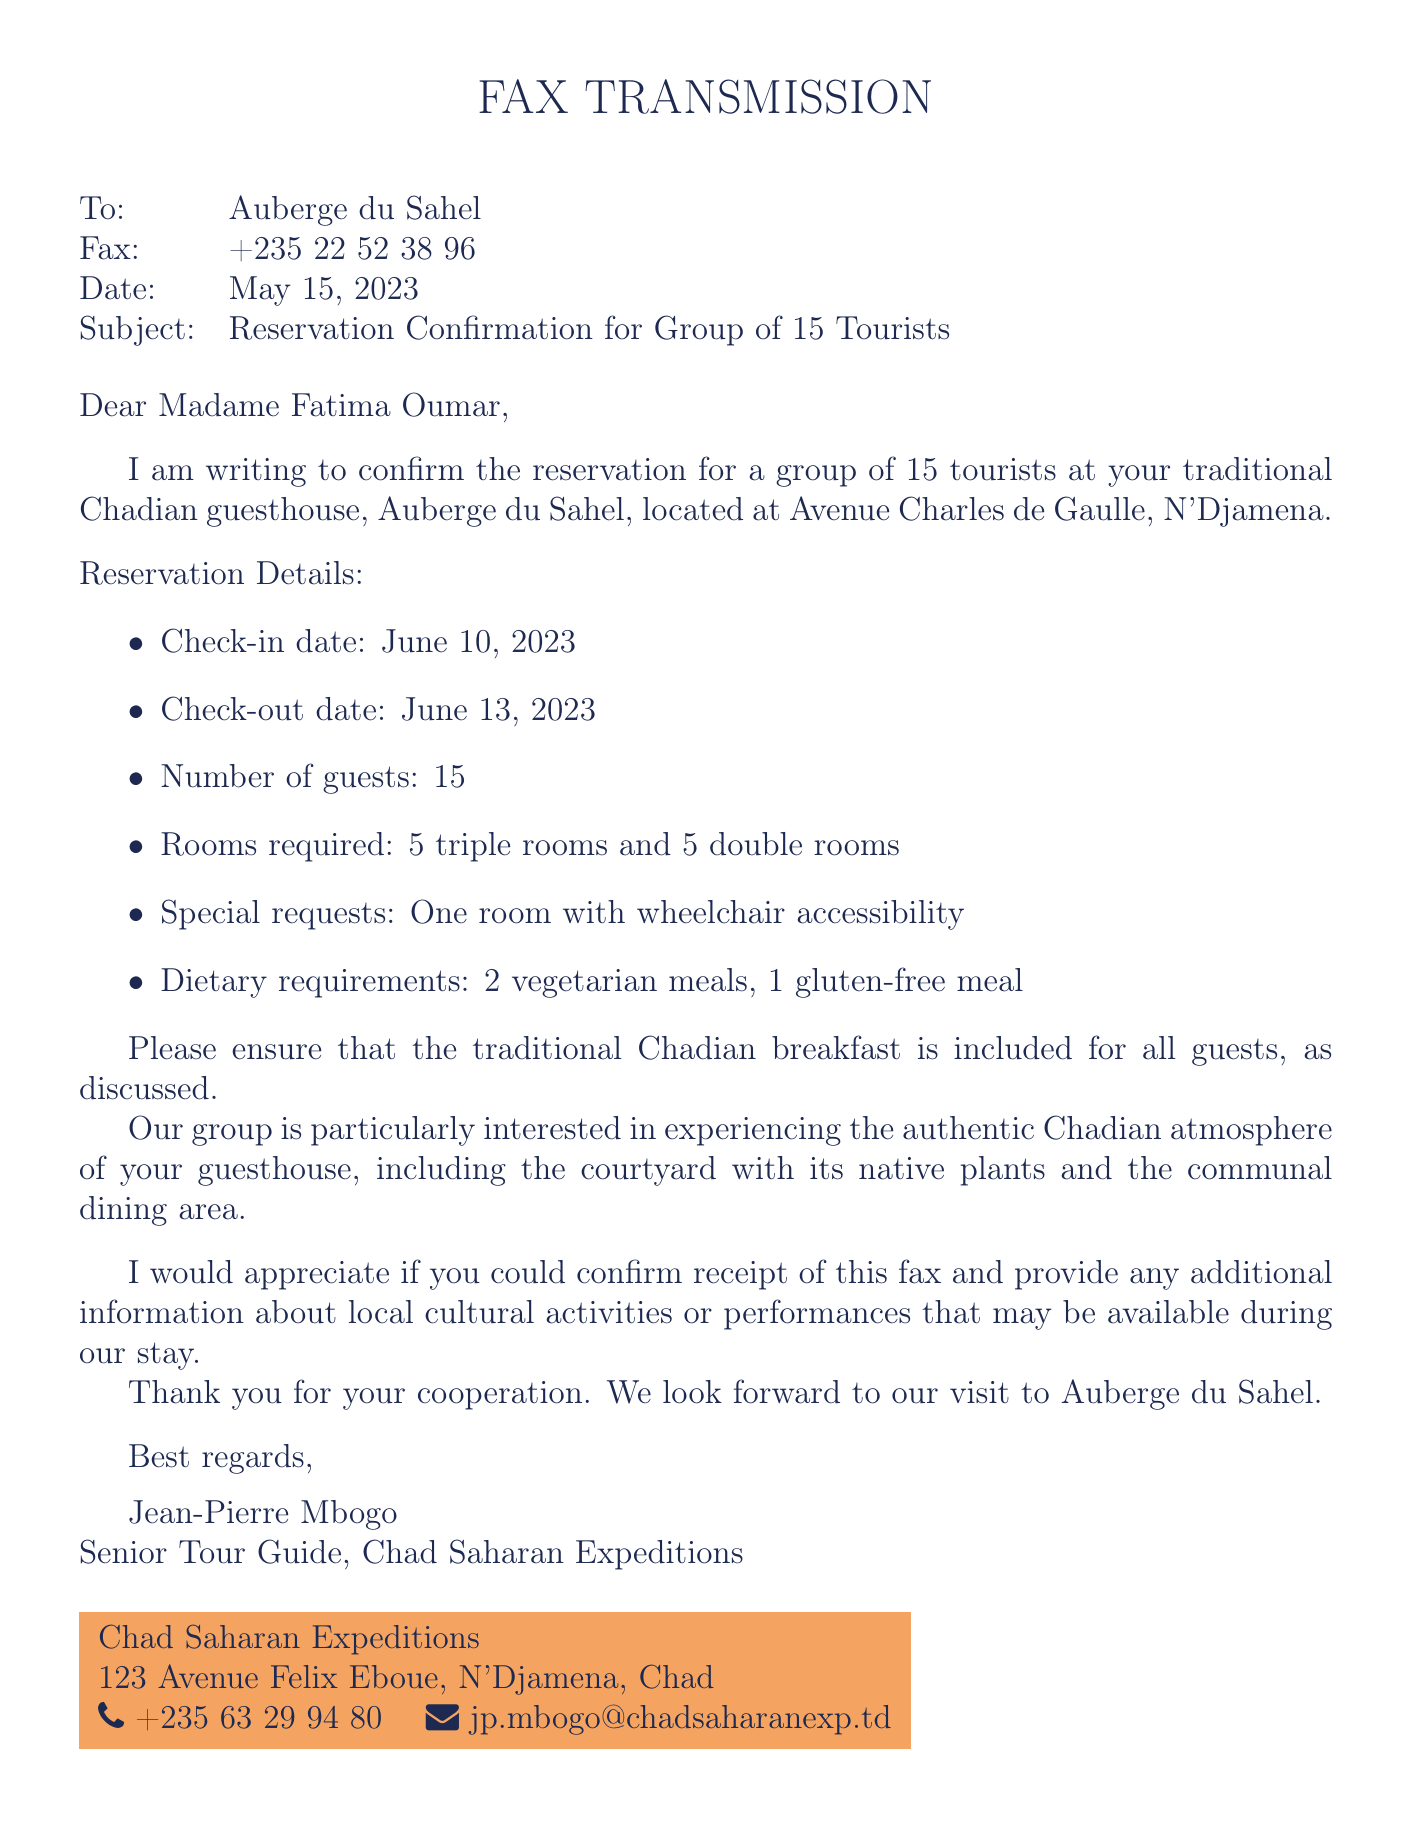what is the date of the fax? The date mentioned in the fax is May 15, 2023.
Answer: May 15, 2023 who is the recipient of the fax? The recipient of the fax is Auberge du Sahel.
Answer: Auberge du Sahel how many guests are in the group? The number of guests in the group is stated as 15.
Answer: 15 what type of special request was made? The fax includes a request for one room with wheelchair accessibility.
Answer: One room with wheelchair accessibility what is included for all guests during their stay? The traditional Chadian breakfast is to be included for all guests.
Answer: Traditional Chadian breakfast how many triple rooms are required? The document specifies that 5 triple rooms are required for the group.
Answer: 5 triple rooms what are the check-in and check-out dates? The check-in date is June 10, 2023, and the check-out date is June 13, 2023.
Answer: June 10, 2023 and June 13, 2023 who sent the fax? The sender of the fax is Jean-Pierre Mbogo.
Answer: Jean-Pierre Mbogo what dietary requirements were mentioned? The specified dietary requirements include 2 vegetarian meals and 1 gluten-free meal.
Answer: 2 vegetarian meals, 1 gluten-free meal 